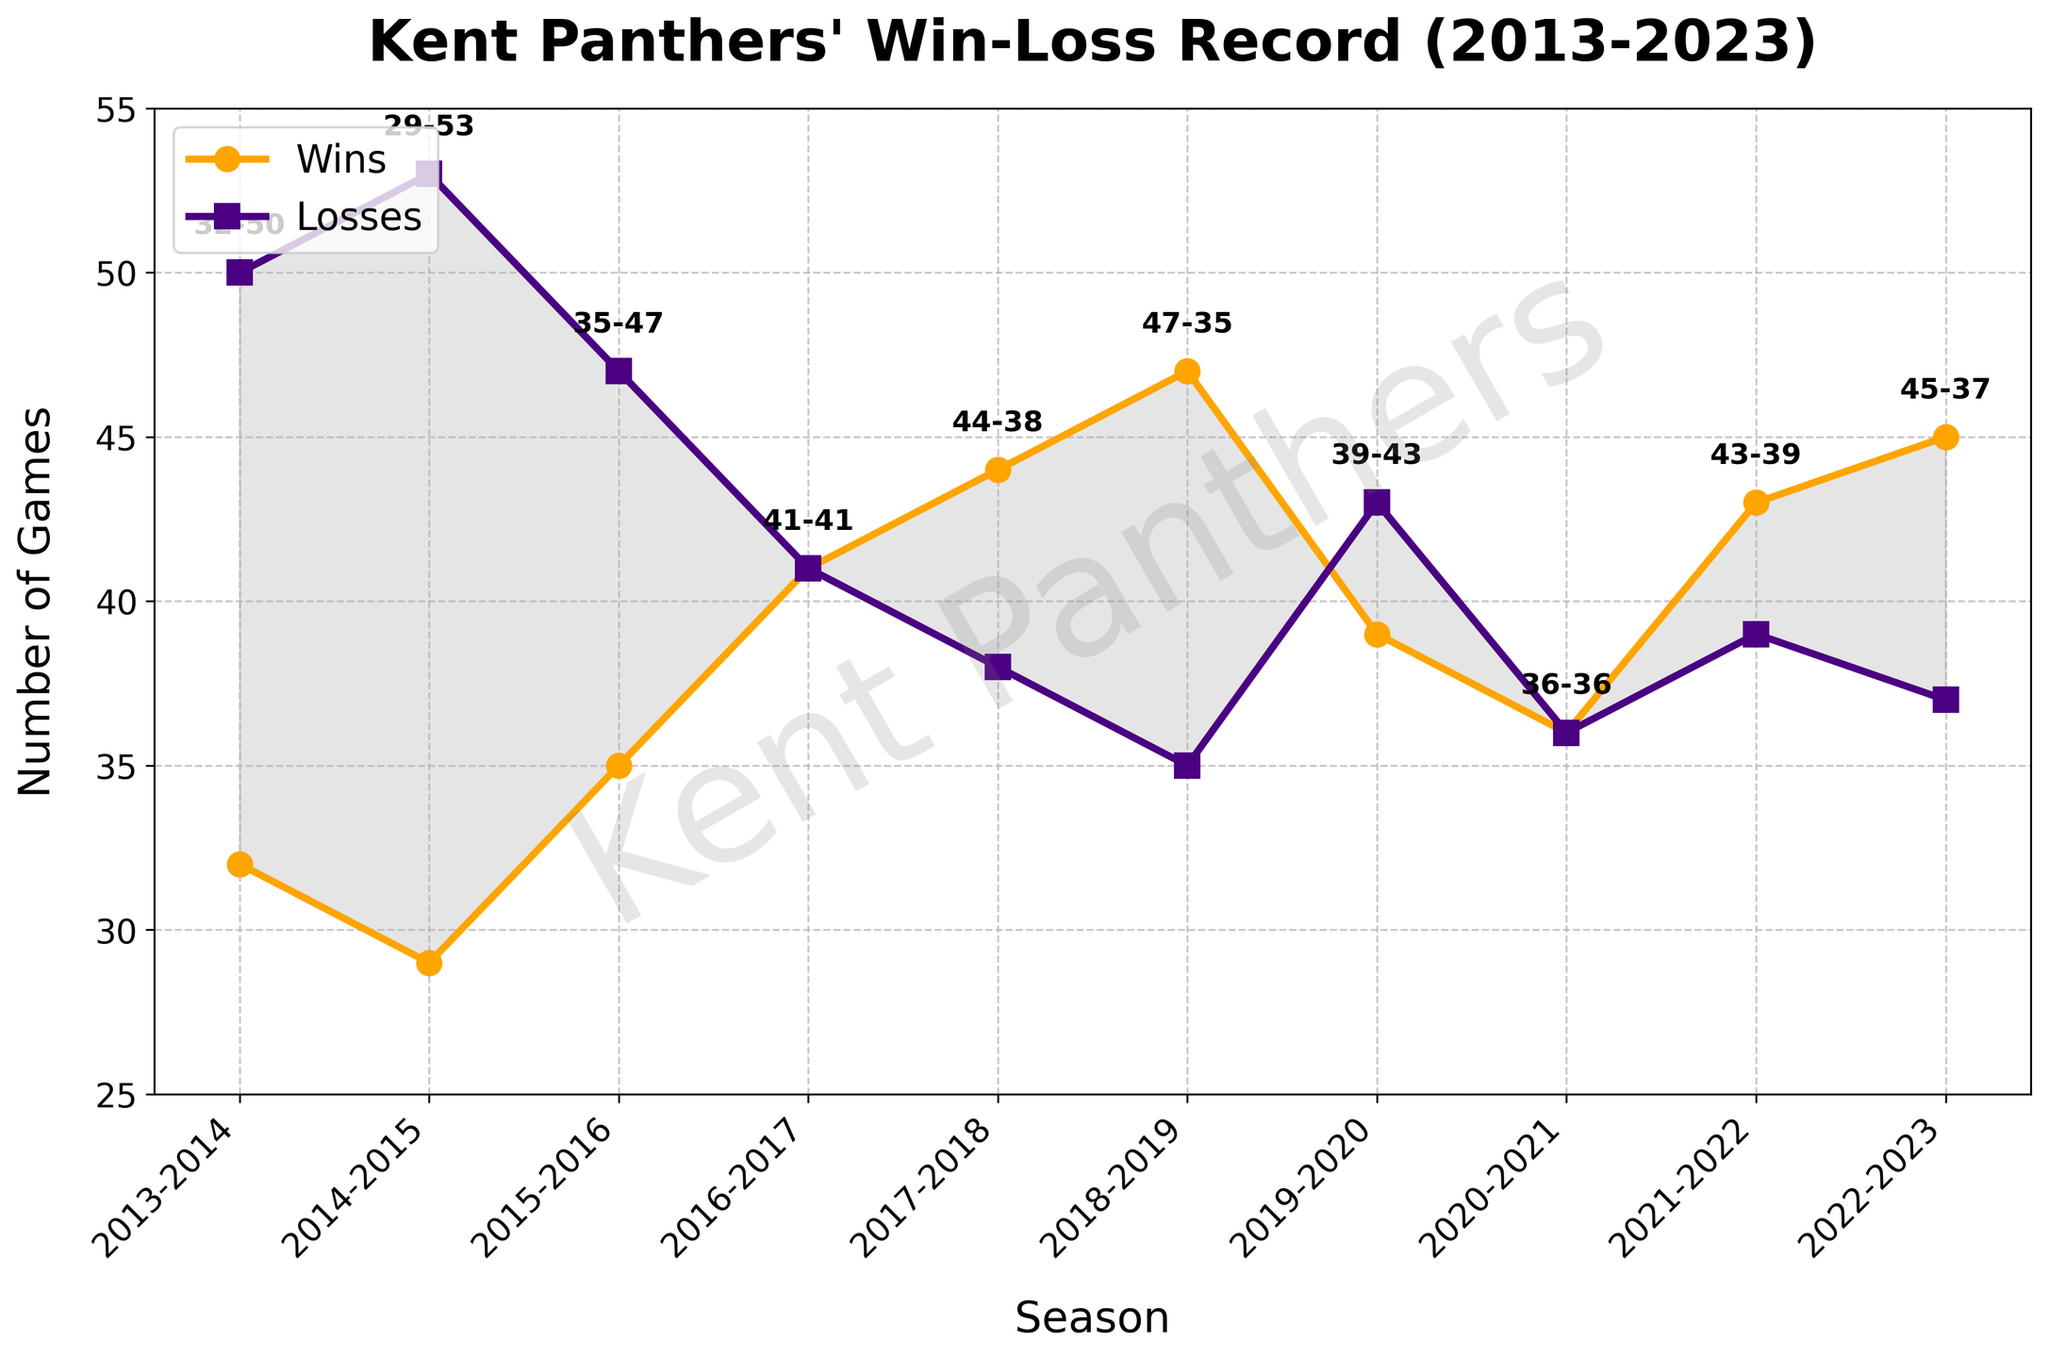How did the win-loss record change from the 2019-2020 season to the 2020-2021 season? To answer this, locate the win-loss records for both seasons. In the 2019-2020 season, the record is 39-43, and in the 2020-2021 season, the record is 36-36. Comparing these, wins decreased by 3 and losses decreased by 7.
Answer: Wins decreased by 3 and losses decreased by 7 Which season has the highest number of wins and what is that number? The highest number of wins is the peak point on the orange line (Wins), which occurs in the 2022-2023 season with 45 wins.
Answer: 2022-2023, 45 wins In which seasons did the Kent Panthers achieve exactly the same number of wins and losses? Look for the overlapping points of the orange and purple lines (Wins and Losses). These occur in the 2016-2017 season and the 2020-2021 season, both with equal wins and losses.
Answer: 2016-2017 and 2020-2021 By how many games did the win-loss record improve from the 2014-2015 season to the 2015-2016 season? Check the win-loss records: 2014-2015 had 29 wins and 53 losses, while 2015-2016 had 35 wins and 47 losses. So the wins improved by 6 and losses decreased by 6. Overall improvement = 6 wins + 6 losses = 12 games.
Answer: 12 games What is the difference in the trend of wins from the 2016-2017 season to the 2017-2018 season? Compare the wins in both seasons: 2016-2017 had 41 wins and 2017-2018 had 44 wins. The wins increased by 3.
Answer: Increased by 3 games What was the largest drop in wins between two consecutive seasons? Examine the orange line for the steepest downward slope between seasons. The largest drop is from the 2018-2019 season (47 wins) to the 2019-2020 season (39 wins), a drop of 8 wins.
Answer: Drop of 8 wins Which season shows the smallest gap between the number of wins and losses? Identify the points where the orange and purple lines are closest. The smallest gap is in the 2020-2021 season with 36 wins and 36 losses, a gap of 0.
Answer: 2020-2021 What season had the greatest total number of games played and what were the totals? Sum the wins and losses for each season. 2014-2015 had 29 wins + 53 losses = 82 games, which is the highest total.
Answer: 2014-2015, 82 games How many seasons had the Kent Panthers winning more games than losing? Count instances where the orange line (Wins) is above the purple line (Losses). These occur in 2015-2016, 2017-2018, 2018-2019, 2021-2022, and 2022-2023, amounting to 5 seasons.
Answer: 5 seasons 